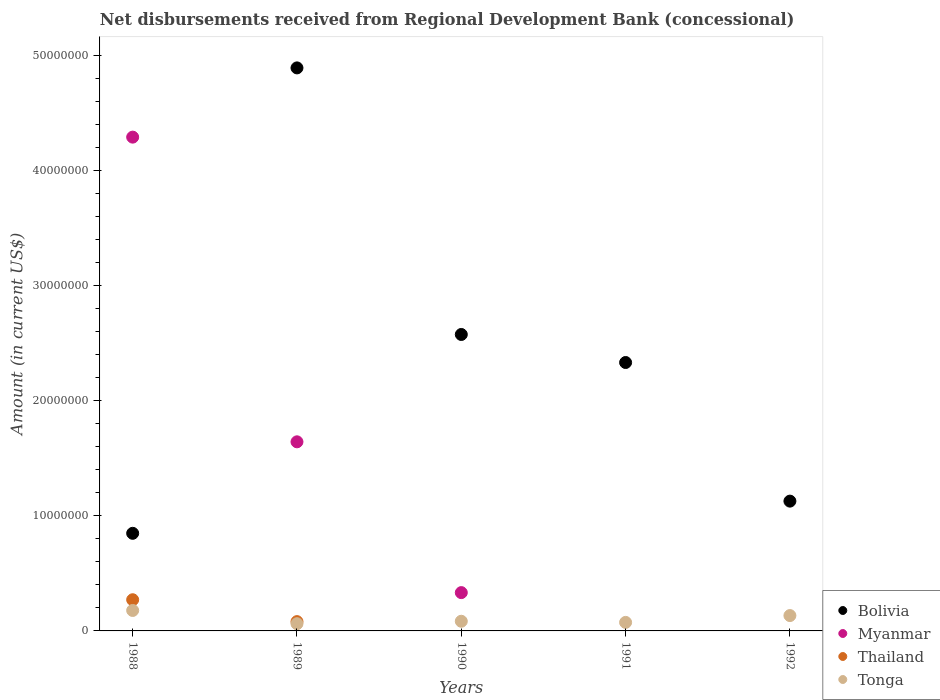Is the number of dotlines equal to the number of legend labels?
Your response must be concise. No. What is the amount of disbursements received from Regional Development Bank in Tonga in 1992?
Your response must be concise. 1.34e+06. Across all years, what is the maximum amount of disbursements received from Regional Development Bank in Bolivia?
Keep it short and to the point. 4.90e+07. What is the total amount of disbursements received from Regional Development Bank in Myanmar in the graph?
Your answer should be compact. 6.27e+07. What is the difference between the amount of disbursements received from Regional Development Bank in Bolivia in 1990 and that in 1992?
Provide a short and direct response. 1.45e+07. What is the difference between the amount of disbursements received from Regional Development Bank in Tonga in 1988 and the amount of disbursements received from Regional Development Bank in Thailand in 1992?
Provide a succinct answer. 1.78e+06. What is the average amount of disbursements received from Regional Development Bank in Thailand per year?
Your answer should be very brief. 7.04e+05. In the year 1990, what is the difference between the amount of disbursements received from Regional Development Bank in Bolivia and amount of disbursements received from Regional Development Bank in Tonga?
Your response must be concise. 2.49e+07. In how many years, is the amount of disbursements received from Regional Development Bank in Tonga greater than 46000000 US$?
Provide a short and direct response. 0. What is the ratio of the amount of disbursements received from Regional Development Bank in Myanmar in 1988 to that in 1989?
Ensure brevity in your answer.  2.61. Is the difference between the amount of disbursements received from Regional Development Bank in Bolivia in 1990 and 1992 greater than the difference between the amount of disbursements received from Regional Development Bank in Tonga in 1990 and 1992?
Your response must be concise. Yes. What is the difference between the highest and the second highest amount of disbursements received from Regional Development Bank in Bolivia?
Provide a short and direct response. 2.32e+07. What is the difference between the highest and the lowest amount of disbursements received from Regional Development Bank in Myanmar?
Offer a very short reply. 4.29e+07. Is the sum of the amount of disbursements received from Regional Development Bank in Myanmar in 1988 and 1990 greater than the maximum amount of disbursements received from Regional Development Bank in Tonga across all years?
Offer a terse response. Yes. Is it the case that in every year, the sum of the amount of disbursements received from Regional Development Bank in Tonga and amount of disbursements received from Regional Development Bank in Thailand  is greater than the sum of amount of disbursements received from Regional Development Bank in Bolivia and amount of disbursements received from Regional Development Bank in Myanmar?
Provide a succinct answer. No. How many dotlines are there?
Provide a short and direct response. 4. Does the graph contain grids?
Offer a very short reply. No. Where does the legend appear in the graph?
Your answer should be compact. Bottom right. What is the title of the graph?
Offer a terse response. Net disbursements received from Regional Development Bank (concessional). Does "South Africa" appear as one of the legend labels in the graph?
Your answer should be very brief. No. What is the label or title of the X-axis?
Ensure brevity in your answer.  Years. What is the Amount (in current US$) of Bolivia in 1988?
Provide a short and direct response. 8.49e+06. What is the Amount (in current US$) of Myanmar in 1988?
Ensure brevity in your answer.  4.29e+07. What is the Amount (in current US$) in Thailand in 1988?
Offer a very short reply. 2.71e+06. What is the Amount (in current US$) of Tonga in 1988?
Provide a succinct answer. 1.78e+06. What is the Amount (in current US$) of Bolivia in 1989?
Make the answer very short. 4.90e+07. What is the Amount (in current US$) of Myanmar in 1989?
Keep it short and to the point. 1.64e+07. What is the Amount (in current US$) of Thailand in 1989?
Your answer should be very brief. 8.09e+05. What is the Amount (in current US$) in Tonga in 1989?
Provide a short and direct response. 6.28e+05. What is the Amount (in current US$) in Bolivia in 1990?
Offer a very short reply. 2.58e+07. What is the Amount (in current US$) of Myanmar in 1990?
Ensure brevity in your answer.  3.33e+06. What is the Amount (in current US$) in Tonga in 1990?
Provide a short and direct response. 8.40e+05. What is the Amount (in current US$) of Bolivia in 1991?
Provide a short and direct response. 2.33e+07. What is the Amount (in current US$) of Tonga in 1991?
Give a very brief answer. 7.41e+05. What is the Amount (in current US$) in Bolivia in 1992?
Provide a succinct answer. 1.13e+07. What is the Amount (in current US$) in Myanmar in 1992?
Make the answer very short. 0. What is the Amount (in current US$) of Thailand in 1992?
Provide a short and direct response. 0. What is the Amount (in current US$) in Tonga in 1992?
Provide a short and direct response. 1.34e+06. Across all years, what is the maximum Amount (in current US$) in Bolivia?
Give a very brief answer. 4.90e+07. Across all years, what is the maximum Amount (in current US$) of Myanmar?
Give a very brief answer. 4.29e+07. Across all years, what is the maximum Amount (in current US$) in Thailand?
Keep it short and to the point. 2.71e+06. Across all years, what is the maximum Amount (in current US$) of Tonga?
Provide a short and direct response. 1.78e+06. Across all years, what is the minimum Amount (in current US$) of Bolivia?
Provide a short and direct response. 8.49e+06. Across all years, what is the minimum Amount (in current US$) of Myanmar?
Ensure brevity in your answer.  0. Across all years, what is the minimum Amount (in current US$) in Tonga?
Provide a succinct answer. 6.28e+05. What is the total Amount (in current US$) of Bolivia in the graph?
Give a very brief answer. 1.18e+08. What is the total Amount (in current US$) of Myanmar in the graph?
Offer a terse response. 6.27e+07. What is the total Amount (in current US$) in Thailand in the graph?
Offer a very short reply. 3.52e+06. What is the total Amount (in current US$) in Tonga in the graph?
Make the answer very short. 5.32e+06. What is the difference between the Amount (in current US$) of Bolivia in 1988 and that in 1989?
Make the answer very short. -4.05e+07. What is the difference between the Amount (in current US$) in Myanmar in 1988 and that in 1989?
Offer a terse response. 2.65e+07. What is the difference between the Amount (in current US$) in Thailand in 1988 and that in 1989?
Ensure brevity in your answer.  1.90e+06. What is the difference between the Amount (in current US$) in Tonga in 1988 and that in 1989?
Keep it short and to the point. 1.15e+06. What is the difference between the Amount (in current US$) in Bolivia in 1988 and that in 1990?
Give a very brief answer. -1.73e+07. What is the difference between the Amount (in current US$) in Myanmar in 1988 and that in 1990?
Make the answer very short. 3.96e+07. What is the difference between the Amount (in current US$) of Tonga in 1988 and that in 1990?
Provide a short and direct response. 9.39e+05. What is the difference between the Amount (in current US$) in Bolivia in 1988 and that in 1991?
Keep it short and to the point. -1.48e+07. What is the difference between the Amount (in current US$) of Tonga in 1988 and that in 1991?
Give a very brief answer. 1.04e+06. What is the difference between the Amount (in current US$) of Bolivia in 1988 and that in 1992?
Provide a succinct answer. -2.80e+06. What is the difference between the Amount (in current US$) in Tonga in 1988 and that in 1992?
Ensure brevity in your answer.  4.44e+05. What is the difference between the Amount (in current US$) of Bolivia in 1989 and that in 1990?
Your answer should be very brief. 2.32e+07. What is the difference between the Amount (in current US$) of Myanmar in 1989 and that in 1990?
Your answer should be compact. 1.31e+07. What is the difference between the Amount (in current US$) of Tonga in 1989 and that in 1990?
Ensure brevity in your answer.  -2.12e+05. What is the difference between the Amount (in current US$) in Bolivia in 1989 and that in 1991?
Your answer should be very brief. 2.56e+07. What is the difference between the Amount (in current US$) in Tonga in 1989 and that in 1991?
Make the answer very short. -1.13e+05. What is the difference between the Amount (in current US$) of Bolivia in 1989 and that in 1992?
Ensure brevity in your answer.  3.77e+07. What is the difference between the Amount (in current US$) in Tonga in 1989 and that in 1992?
Make the answer very short. -7.07e+05. What is the difference between the Amount (in current US$) of Bolivia in 1990 and that in 1991?
Your answer should be compact. 2.44e+06. What is the difference between the Amount (in current US$) in Tonga in 1990 and that in 1991?
Offer a very short reply. 9.90e+04. What is the difference between the Amount (in current US$) of Bolivia in 1990 and that in 1992?
Provide a short and direct response. 1.45e+07. What is the difference between the Amount (in current US$) in Tonga in 1990 and that in 1992?
Give a very brief answer. -4.95e+05. What is the difference between the Amount (in current US$) of Bolivia in 1991 and that in 1992?
Provide a succinct answer. 1.21e+07. What is the difference between the Amount (in current US$) in Tonga in 1991 and that in 1992?
Your answer should be compact. -5.94e+05. What is the difference between the Amount (in current US$) in Bolivia in 1988 and the Amount (in current US$) in Myanmar in 1989?
Provide a short and direct response. -7.96e+06. What is the difference between the Amount (in current US$) in Bolivia in 1988 and the Amount (in current US$) in Thailand in 1989?
Offer a very short reply. 7.68e+06. What is the difference between the Amount (in current US$) in Bolivia in 1988 and the Amount (in current US$) in Tonga in 1989?
Your answer should be very brief. 7.86e+06. What is the difference between the Amount (in current US$) in Myanmar in 1988 and the Amount (in current US$) in Thailand in 1989?
Ensure brevity in your answer.  4.21e+07. What is the difference between the Amount (in current US$) in Myanmar in 1988 and the Amount (in current US$) in Tonga in 1989?
Your answer should be very brief. 4.23e+07. What is the difference between the Amount (in current US$) in Thailand in 1988 and the Amount (in current US$) in Tonga in 1989?
Provide a short and direct response. 2.08e+06. What is the difference between the Amount (in current US$) of Bolivia in 1988 and the Amount (in current US$) of Myanmar in 1990?
Offer a terse response. 5.16e+06. What is the difference between the Amount (in current US$) of Bolivia in 1988 and the Amount (in current US$) of Tonga in 1990?
Keep it short and to the point. 7.65e+06. What is the difference between the Amount (in current US$) of Myanmar in 1988 and the Amount (in current US$) of Tonga in 1990?
Ensure brevity in your answer.  4.21e+07. What is the difference between the Amount (in current US$) of Thailand in 1988 and the Amount (in current US$) of Tonga in 1990?
Ensure brevity in your answer.  1.87e+06. What is the difference between the Amount (in current US$) in Bolivia in 1988 and the Amount (in current US$) in Tonga in 1991?
Your response must be concise. 7.74e+06. What is the difference between the Amount (in current US$) of Myanmar in 1988 and the Amount (in current US$) of Tonga in 1991?
Keep it short and to the point. 4.22e+07. What is the difference between the Amount (in current US$) of Thailand in 1988 and the Amount (in current US$) of Tonga in 1991?
Provide a succinct answer. 1.97e+06. What is the difference between the Amount (in current US$) in Bolivia in 1988 and the Amount (in current US$) in Tonga in 1992?
Make the answer very short. 7.15e+06. What is the difference between the Amount (in current US$) of Myanmar in 1988 and the Amount (in current US$) of Tonga in 1992?
Give a very brief answer. 4.16e+07. What is the difference between the Amount (in current US$) in Thailand in 1988 and the Amount (in current US$) in Tonga in 1992?
Ensure brevity in your answer.  1.38e+06. What is the difference between the Amount (in current US$) of Bolivia in 1989 and the Amount (in current US$) of Myanmar in 1990?
Your answer should be very brief. 4.56e+07. What is the difference between the Amount (in current US$) in Bolivia in 1989 and the Amount (in current US$) in Tonga in 1990?
Provide a succinct answer. 4.81e+07. What is the difference between the Amount (in current US$) in Myanmar in 1989 and the Amount (in current US$) in Tonga in 1990?
Your answer should be very brief. 1.56e+07. What is the difference between the Amount (in current US$) of Thailand in 1989 and the Amount (in current US$) of Tonga in 1990?
Ensure brevity in your answer.  -3.10e+04. What is the difference between the Amount (in current US$) in Bolivia in 1989 and the Amount (in current US$) in Tonga in 1991?
Provide a succinct answer. 4.82e+07. What is the difference between the Amount (in current US$) in Myanmar in 1989 and the Amount (in current US$) in Tonga in 1991?
Offer a very short reply. 1.57e+07. What is the difference between the Amount (in current US$) in Thailand in 1989 and the Amount (in current US$) in Tonga in 1991?
Your response must be concise. 6.80e+04. What is the difference between the Amount (in current US$) of Bolivia in 1989 and the Amount (in current US$) of Tonga in 1992?
Your answer should be very brief. 4.76e+07. What is the difference between the Amount (in current US$) in Myanmar in 1989 and the Amount (in current US$) in Tonga in 1992?
Make the answer very short. 1.51e+07. What is the difference between the Amount (in current US$) of Thailand in 1989 and the Amount (in current US$) of Tonga in 1992?
Offer a terse response. -5.26e+05. What is the difference between the Amount (in current US$) of Bolivia in 1990 and the Amount (in current US$) of Tonga in 1991?
Your answer should be compact. 2.50e+07. What is the difference between the Amount (in current US$) of Myanmar in 1990 and the Amount (in current US$) of Tonga in 1991?
Your answer should be compact. 2.59e+06. What is the difference between the Amount (in current US$) of Bolivia in 1990 and the Amount (in current US$) of Tonga in 1992?
Give a very brief answer. 2.44e+07. What is the difference between the Amount (in current US$) of Myanmar in 1990 and the Amount (in current US$) of Tonga in 1992?
Keep it short and to the point. 2.00e+06. What is the difference between the Amount (in current US$) of Bolivia in 1991 and the Amount (in current US$) of Tonga in 1992?
Offer a terse response. 2.20e+07. What is the average Amount (in current US$) in Bolivia per year?
Ensure brevity in your answer.  2.36e+07. What is the average Amount (in current US$) in Myanmar per year?
Offer a terse response. 1.25e+07. What is the average Amount (in current US$) in Thailand per year?
Your response must be concise. 7.04e+05. What is the average Amount (in current US$) of Tonga per year?
Make the answer very short. 1.06e+06. In the year 1988, what is the difference between the Amount (in current US$) of Bolivia and Amount (in current US$) of Myanmar?
Your answer should be very brief. -3.44e+07. In the year 1988, what is the difference between the Amount (in current US$) in Bolivia and Amount (in current US$) in Thailand?
Ensure brevity in your answer.  5.78e+06. In the year 1988, what is the difference between the Amount (in current US$) in Bolivia and Amount (in current US$) in Tonga?
Give a very brief answer. 6.71e+06. In the year 1988, what is the difference between the Amount (in current US$) in Myanmar and Amount (in current US$) in Thailand?
Your response must be concise. 4.02e+07. In the year 1988, what is the difference between the Amount (in current US$) in Myanmar and Amount (in current US$) in Tonga?
Your answer should be very brief. 4.12e+07. In the year 1988, what is the difference between the Amount (in current US$) of Thailand and Amount (in current US$) of Tonga?
Provide a short and direct response. 9.32e+05. In the year 1989, what is the difference between the Amount (in current US$) of Bolivia and Amount (in current US$) of Myanmar?
Provide a succinct answer. 3.25e+07. In the year 1989, what is the difference between the Amount (in current US$) in Bolivia and Amount (in current US$) in Thailand?
Offer a terse response. 4.81e+07. In the year 1989, what is the difference between the Amount (in current US$) of Bolivia and Amount (in current US$) of Tonga?
Your answer should be very brief. 4.83e+07. In the year 1989, what is the difference between the Amount (in current US$) of Myanmar and Amount (in current US$) of Thailand?
Keep it short and to the point. 1.56e+07. In the year 1989, what is the difference between the Amount (in current US$) in Myanmar and Amount (in current US$) in Tonga?
Provide a succinct answer. 1.58e+07. In the year 1989, what is the difference between the Amount (in current US$) of Thailand and Amount (in current US$) of Tonga?
Make the answer very short. 1.81e+05. In the year 1990, what is the difference between the Amount (in current US$) in Bolivia and Amount (in current US$) in Myanmar?
Provide a short and direct response. 2.24e+07. In the year 1990, what is the difference between the Amount (in current US$) in Bolivia and Amount (in current US$) in Tonga?
Your answer should be very brief. 2.49e+07. In the year 1990, what is the difference between the Amount (in current US$) in Myanmar and Amount (in current US$) in Tonga?
Make the answer very short. 2.49e+06. In the year 1991, what is the difference between the Amount (in current US$) of Bolivia and Amount (in current US$) of Tonga?
Your response must be concise. 2.26e+07. In the year 1992, what is the difference between the Amount (in current US$) of Bolivia and Amount (in current US$) of Tonga?
Offer a terse response. 9.95e+06. What is the ratio of the Amount (in current US$) in Bolivia in 1988 to that in 1989?
Offer a terse response. 0.17. What is the ratio of the Amount (in current US$) of Myanmar in 1988 to that in 1989?
Provide a short and direct response. 2.61. What is the ratio of the Amount (in current US$) of Thailand in 1988 to that in 1989?
Give a very brief answer. 3.35. What is the ratio of the Amount (in current US$) of Tonga in 1988 to that in 1989?
Make the answer very short. 2.83. What is the ratio of the Amount (in current US$) of Bolivia in 1988 to that in 1990?
Your response must be concise. 0.33. What is the ratio of the Amount (in current US$) in Myanmar in 1988 to that in 1990?
Provide a short and direct response. 12.89. What is the ratio of the Amount (in current US$) of Tonga in 1988 to that in 1990?
Your answer should be very brief. 2.12. What is the ratio of the Amount (in current US$) in Bolivia in 1988 to that in 1991?
Ensure brevity in your answer.  0.36. What is the ratio of the Amount (in current US$) of Tonga in 1988 to that in 1991?
Give a very brief answer. 2.4. What is the ratio of the Amount (in current US$) in Bolivia in 1988 to that in 1992?
Ensure brevity in your answer.  0.75. What is the ratio of the Amount (in current US$) of Tonga in 1988 to that in 1992?
Make the answer very short. 1.33. What is the ratio of the Amount (in current US$) in Bolivia in 1989 to that in 1990?
Offer a very short reply. 1.9. What is the ratio of the Amount (in current US$) in Myanmar in 1989 to that in 1990?
Give a very brief answer. 4.94. What is the ratio of the Amount (in current US$) of Tonga in 1989 to that in 1990?
Keep it short and to the point. 0.75. What is the ratio of the Amount (in current US$) of Bolivia in 1989 to that in 1991?
Offer a very short reply. 2.1. What is the ratio of the Amount (in current US$) of Tonga in 1989 to that in 1991?
Your response must be concise. 0.85. What is the ratio of the Amount (in current US$) in Bolivia in 1989 to that in 1992?
Your response must be concise. 4.34. What is the ratio of the Amount (in current US$) of Tonga in 1989 to that in 1992?
Offer a very short reply. 0.47. What is the ratio of the Amount (in current US$) in Bolivia in 1990 to that in 1991?
Provide a succinct answer. 1.1. What is the ratio of the Amount (in current US$) of Tonga in 1990 to that in 1991?
Give a very brief answer. 1.13. What is the ratio of the Amount (in current US$) of Bolivia in 1990 to that in 1992?
Ensure brevity in your answer.  2.28. What is the ratio of the Amount (in current US$) in Tonga in 1990 to that in 1992?
Provide a short and direct response. 0.63. What is the ratio of the Amount (in current US$) in Bolivia in 1991 to that in 1992?
Give a very brief answer. 2.07. What is the ratio of the Amount (in current US$) in Tonga in 1991 to that in 1992?
Your answer should be compact. 0.56. What is the difference between the highest and the second highest Amount (in current US$) of Bolivia?
Your answer should be compact. 2.32e+07. What is the difference between the highest and the second highest Amount (in current US$) in Myanmar?
Provide a succinct answer. 2.65e+07. What is the difference between the highest and the second highest Amount (in current US$) in Tonga?
Offer a very short reply. 4.44e+05. What is the difference between the highest and the lowest Amount (in current US$) of Bolivia?
Your response must be concise. 4.05e+07. What is the difference between the highest and the lowest Amount (in current US$) of Myanmar?
Provide a succinct answer. 4.29e+07. What is the difference between the highest and the lowest Amount (in current US$) of Thailand?
Offer a very short reply. 2.71e+06. What is the difference between the highest and the lowest Amount (in current US$) of Tonga?
Offer a very short reply. 1.15e+06. 